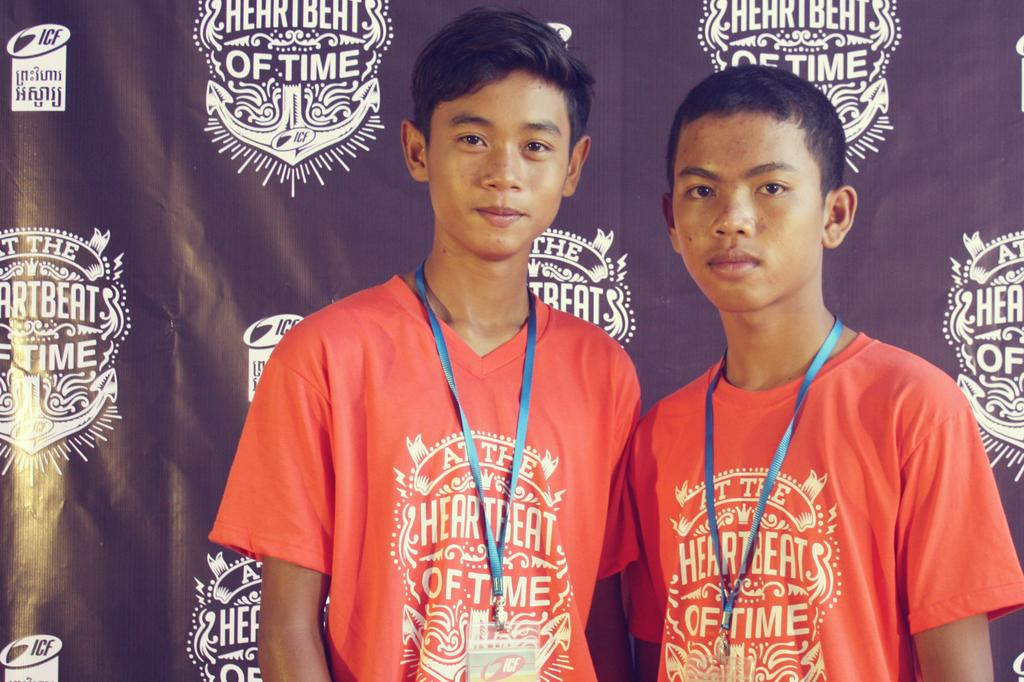Provide a one-sentence caption for the provided image. Two kids with a shirt saying at the heartbeat of time. 